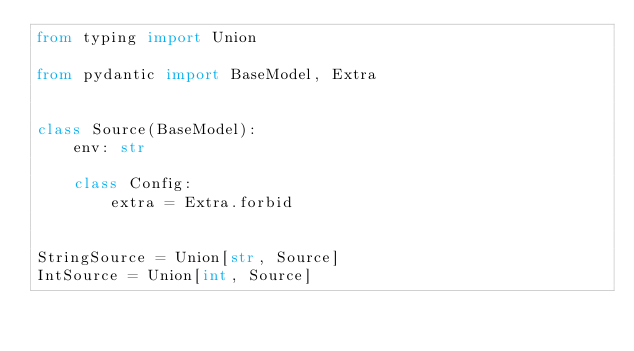<code> <loc_0><loc_0><loc_500><loc_500><_Python_>from typing import Union

from pydantic import BaseModel, Extra


class Source(BaseModel):
    env: str

    class Config:
        extra = Extra.forbid


StringSource = Union[str, Source]
IntSource = Union[int, Source]
</code> 